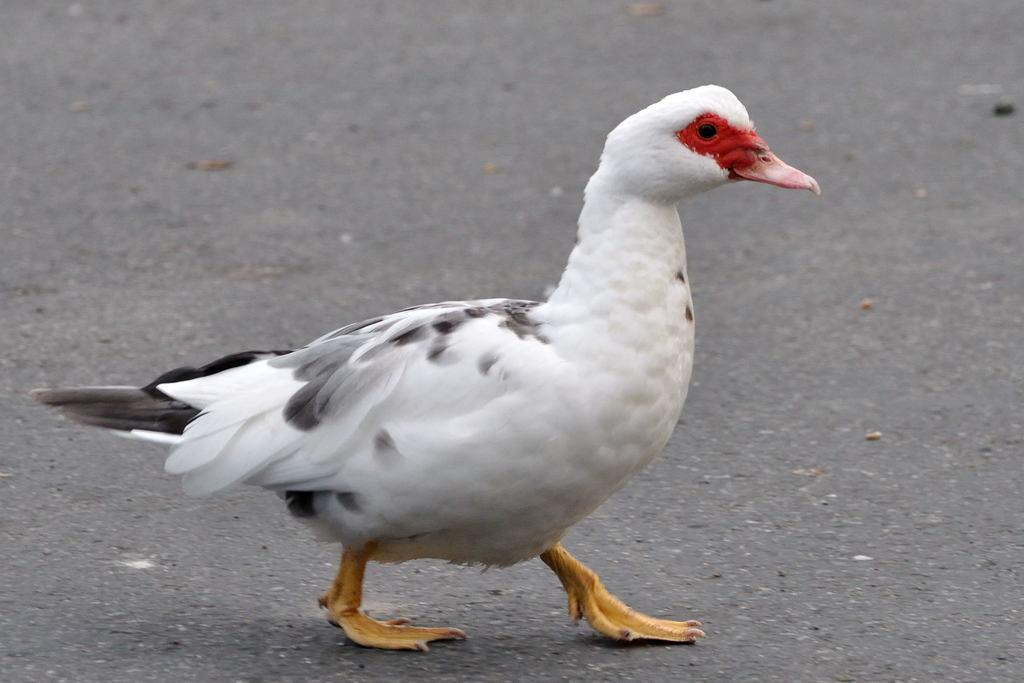What animal is present in the picture? There is a duck in the picture. What is the duck doing in the picture? The duck is moving. What colors can be seen on the duck? The duck is white and black in color. What type of railway system is visible in the image? There is no railway system present in the image; it features a duck that is moving. How many wings does the duck have in the image? Ducks typically have two wings, but since the image only shows the duck from the front, it is not possible to determine the number of wings visible. 